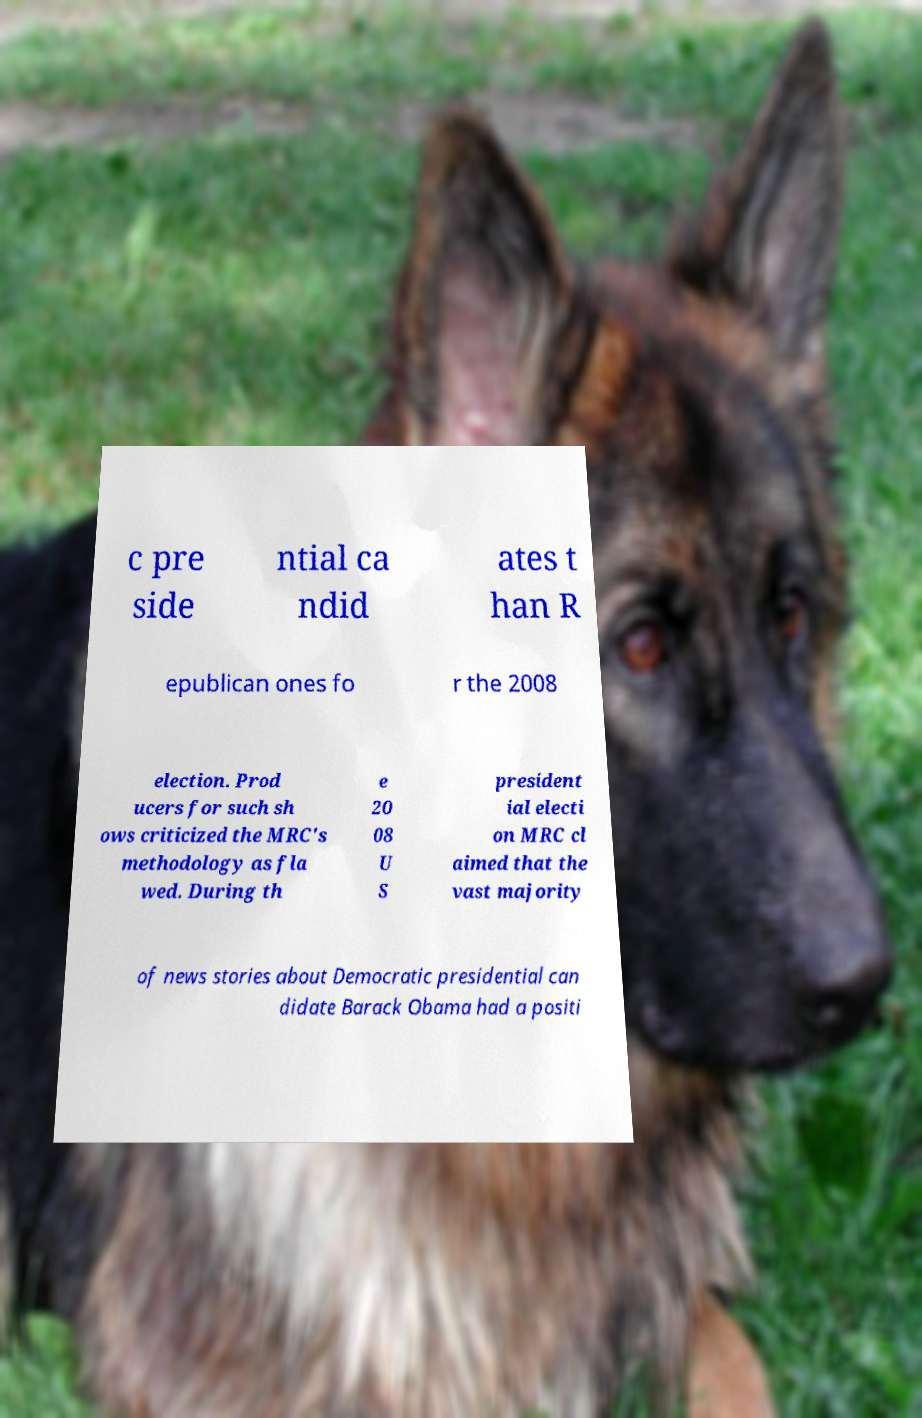Please identify and transcribe the text found in this image. c pre side ntial ca ndid ates t han R epublican ones fo r the 2008 election. Prod ucers for such sh ows criticized the MRC's methodology as fla wed. During th e 20 08 U S president ial electi on MRC cl aimed that the vast majority of news stories about Democratic presidential can didate Barack Obama had a positi 